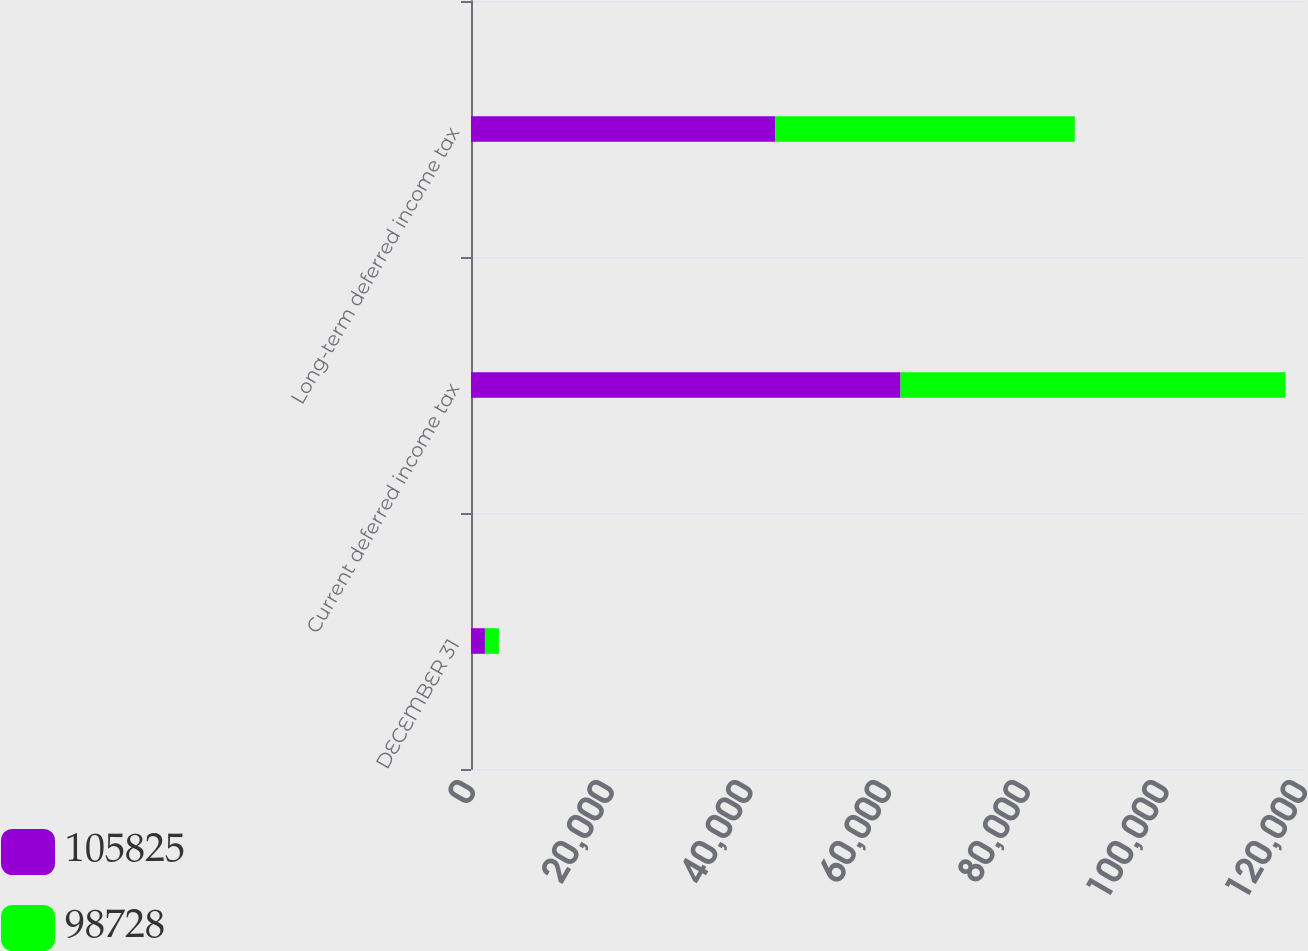Convert chart. <chart><loc_0><loc_0><loc_500><loc_500><stacked_bar_chart><ecel><fcel>DECEMBER 31<fcel>Current deferred income tax<fcel>Long-term deferred income tax<nl><fcel>105825<fcel>2008<fcel>61955<fcel>43870<nl><fcel>98728<fcel>2007<fcel>55522<fcel>43206<nl></chart> 